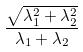Convert formula to latex. <formula><loc_0><loc_0><loc_500><loc_500>\frac { \sqrt { \lambda _ { 1 } ^ { 2 } + \lambda _ { 2 } ^ { 2 } } } { \lambda _ { 1 } + \lambda _ { 2 } }</formula> 